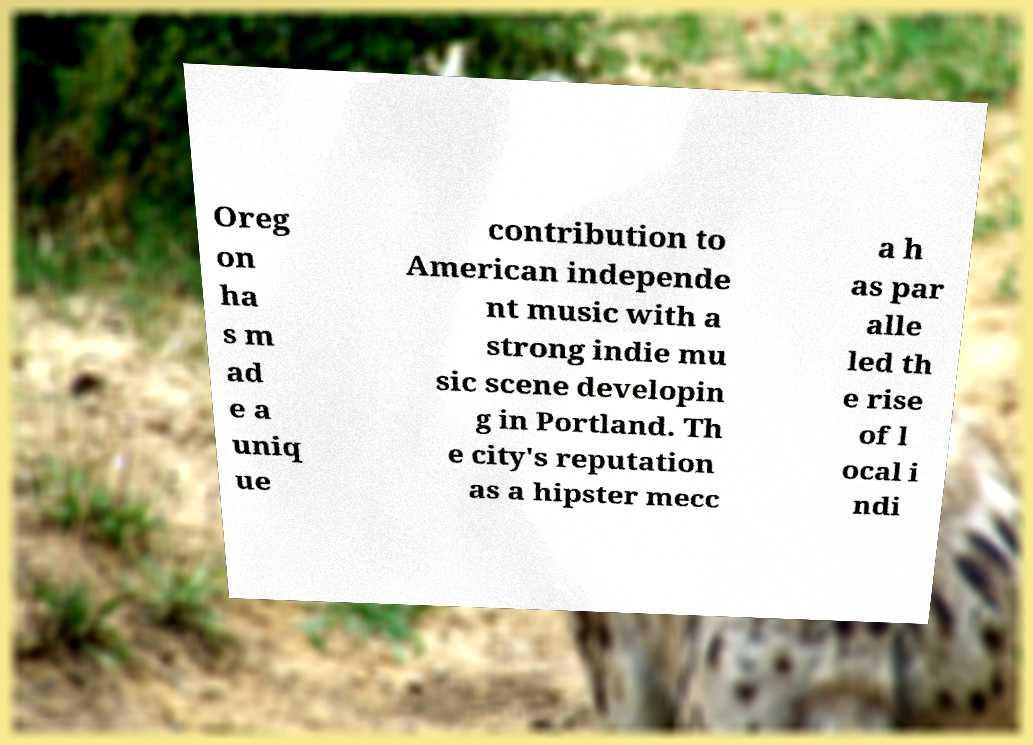There's text embedded in this image that I need extracted. Can you transcribe it verbatim? Oreg on ha s m ad e a uniq ue contribution to American independe nt music with a strong indie mu sic scene developin g in Portland. Th e city's reputation as a hipster mecc a h as par alle led th e rise of l ocal i ndi 